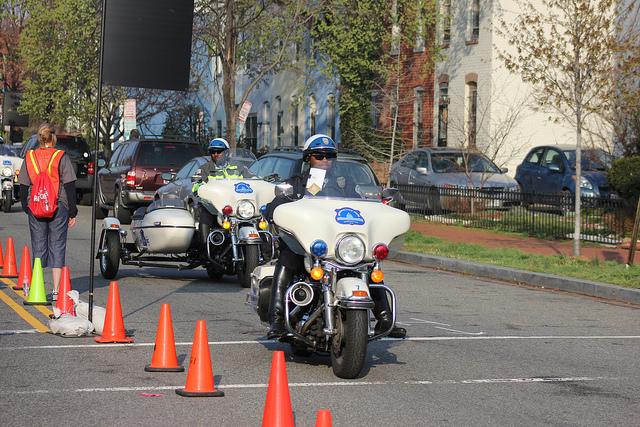Is there a parade going on in this picture?
Quick response, please. No. Are these policemen in a street parade?
Concise answer only. Yes. How many yellow cones are there?
Concise answer only. 1. What are all these motorbikes doing there?
Quick response, please. Riding. 